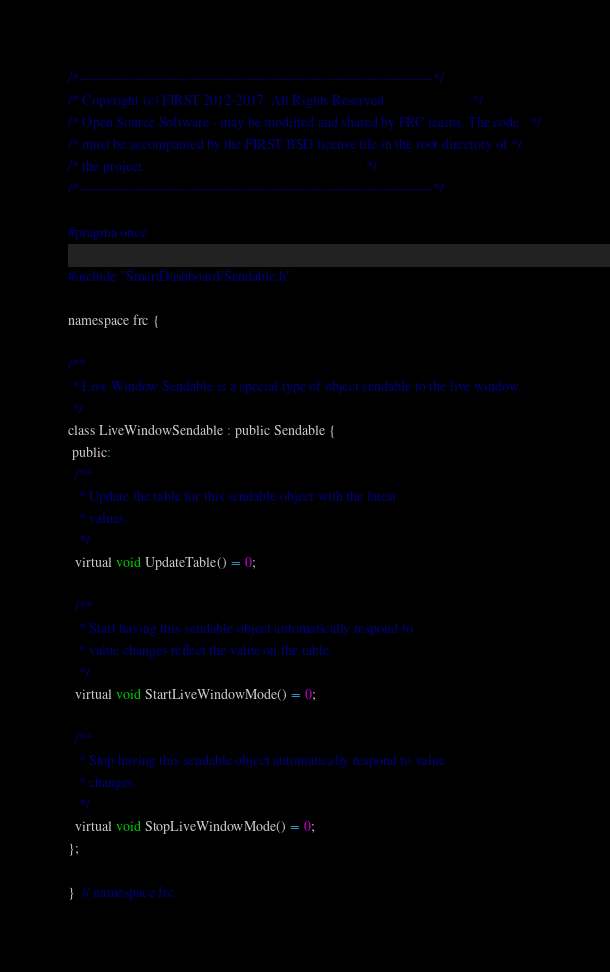Convert code to text. <code><loc_0><loc_0><loc_500><loc_500><_C_>/*----------------------------------------------------------------------------*/
/* Copyright (c) FIRST 2012-2017. All Rights Reserved.                        */
/* Open Source Software - may be modified and shared by FRC teams. The code   */
/* must be accompanied by the FIRST BSD license file in the root directory of */
/* the project.                                                               */
/*----------------------------------------------------------------------------*/

#pragma once

#include "SmartDashboard/Sendable.h"

namespace frc {

/**
 * Live Window Sendable is a special type of object sendable to the live window.
 */
class LiveWindowSendable : public Sendable {
 public:
  /**
   * Update the table for this sendable object with the latest
   * values.
   */
  virtual void UpdateTable() = 0;

  /**
   * Start having this sendable object automatically respond to
   * value changes reflect the value on the table.
   */
  virtual void StartLiveWindowMode() = 0;

  /**
   * Stop having this sendable object automatically respond to value
   * changes.
   */
  virtual void StopLiveWindowMode() = 0;
};

}  // namespace frc
</code> 